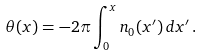<formula> <loc_0><loc_0><loc_500><loc_500>\theta ( x ) = - 2 \pi \int _ { 0 } ^ { x } n _ { 0 } ( x ^ { \prime } ) \, d x ^ { \prime } \, .</formula> 